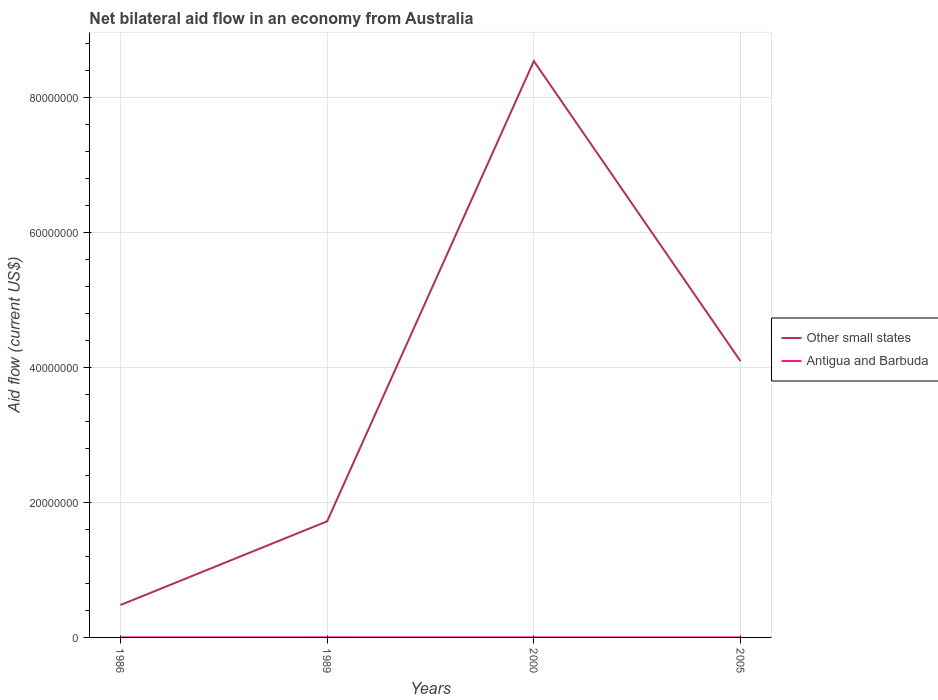Does the line corresponding to Other small states intersect with the line corresponding to Antigua and Barbuda?
Ensure brevity in your answer.  No. Is the number of lines equal to the number of legend labels?
Make the answer very short. Yes. Across all years, what is the maximum net bilateral aid flow in Antigua and Barbuda?
Offer a very short reply. 10000. In which year was the net bilateral aid flow in Antigua and Barbuda maximum?
Make the answer very short. 1986. What is the total net bilateral aid flow in Antigua and Barbuda in the graph?
Your answer should be very brief. 0. What is the difference between the highest and the second highest net bilateral aid flow in Other small states?
Ensure brevity in your answer.  8.06e+07. How many years are there in the graph?
Your answer should be compact. 4. Does the graph contain any zero values?
Give a very brief answer. No. Does the graph contain grids?
Your response must be concise. Yes. Where does the legend appear in the graph?
Keep it short and to the point. Center right. How are the legend labels stacked?
Offer a very short reply. Vertical. What is the title of the graph?
Keep it short and to the point. Net bilateral aid flow in an economy from Australia. Does "High income: OECD" appear as one of the legend labels in the graph?
Your response must be concise. No. What is the Aid flow (current US$) in Other small states in 1986?
Offer a very short reply. 4.80e+06. What is the Aid flow (current US$) in Other small states in 1989?
Offer a very short reply. 1.72e+07. What is the Aid flow (current US$) in Other small states in 2000?
Your answer should be very brief. 8.54e+07. What is the Aid flow (current US$) of Antigua and Barbuda in 2000?
Your answer should be compact. 10000. What is the Aid flow (current US$) of Other small states in 2005?
Keep it short and to the point. 4.09e+07. What is the Aid flow (current US$) in Antigua and Barbuda in 2005?
Provide a short and direct response. 10000. Across all years, what is the maximum Aid flow (current US$) in Other small states?
Provide a short and direct response. 8.54e+07. Across all years, what is the maximum Aid flow (current US$) of Antigua and Barbuda?
Make the answer very short. 2.00e+04. Across all years, what is the minimum Aid flow (current US$) in Other small states?
Provide a succinct answer. 4.80e+06. Across all years, what is the minimum Aid flow (current US$) of Antigua and Barbuda?
Ensure brevity in your answer.  10000. What is the total Aid flow (current US$) in Other small states in the graph?
Keep it short and to the point. 1.48e+08. What is the difference between the Aid flow (current US$) in Other small states in 1986 and that in 1989?
Ensure brevity in your answer.  -1.24e+07. What is the difference between the Aid flow (current US$) in Other small states in 1986 and that in 2000?
Make the answer very short. -8.06e+07. What is the difference between the Aid flow (current US$) in Other small states in 1986 and that in 2005?
Your response must be concise. -3.61e+07. What is the difference between the Aid flow (current US$) of Other small states in 1989 and that in 2000?
Ensure brevity in your answer.  -6.82e+07. What is the difference between the Aid flow (current US$) of Other small states in 1989 and that in 2005?
Make the answer very short. -2.37e+07. What is the difference between the Aid flow (current US$) in Antigua and Barbuda in 1989 and that in 2005?
Ensure brevity in your answer.  10000. What is the difference between the Aid flow (current US$) of Other small states in 2000 and that in 2005?
Provide a succinct answer. 4.45e+07. What is the difference between the Aid flow (current US$) of Other small states in 1986 and the Aid flow (current US$) of Antigua and Barbuda in 1989?
Provide a succinct answer. 4.78e+06. What is the difference between the Aid flow (current US$) of Other small states in 1986 and the Aid flow (current US$) of Antigua and Barbuda in 2000?
Provide a short and direct response. 4.79e+06. What is the difference between the Aid flow (current US$) in Other small states in 1986 and the Aid flow (current US$) in Antigua and Barbuda in 2005?
Offer a very short reply. 4.79e+06. What is the difference between the Aid flow (current US$) in Other small states in 1989 and the Aid flow (current US$) in Antigua and Barbuda in 2000?
Your response must be concise. 1.72e+07. What is the difference between the Aid flow (current US$) in Other small states in 1989 and the Aid flow (current US$) in Antigua and Barbuda in 2005?
Offer a very short reply. 1.72e+07. What is the difference between the Aid flow (current US$) of Other small states in 2000 and the Aid flow (current US$) of Antigua and Barbuda in 2005?
Keep it short and to the point. 8.54e+07. What is the average Aid flow (current US$) in Other small states per year?
Make the answer very short. 3.71e+07. What is the average Aid flow (current US$) of Antigua and Barbuda per year?
Offer a terse response. 1.25e+04. In the year 1986, what is the difference between the Aid flow (current US$) of Other small states and Aid flow (current US$) of Antigua and Barbuda?
Offer a terse response. 4.79e+06. In the year 1989, what is the difference between the Aid flow (current US$) in Other small states and Aid flow (current US$) in Antigua and Barbuda?
Your response must be concise. 1.72e+07. In the year 2000, what is the difference between the Aid flow (current US$) in Other small states and Aid flow (current US$) in Antigua and Barbuda?
Make the answer very short. 8.54e+07. In the year 2005, what is the difference between the Aid flow (current US$) in Other small states and Aid flow (current US$) in Antigua and Barbuda?
Provide a short and direct response. 4.09e+07. What is the ratio of the Aid flow (current US$) of Other small states in 1986 to that in 1989?
Offer a very short reply. 0.28. What is the ratio of the Aid flow (current US$) in Antigua and Barbuda in 1986 to that in 1989?
Your answer should be very brief. 0.5. What is the ratio of the Aid flow (current US$) of Other small states in 1986 to that in 2000?
Give a very brief answer. 0.06. What is the ratio of the Aid flow (current US$) of Other small states in 1986 to that in 2005?
Offer a very short reply. 0.12. What is the ratio of the Aid flow (current US$) in Antigua and Barbuda in 1986 to that in 2005?
Your answer should be compact. 1. What is the ratio of the Aid flow (current US$) of Other small states in 1989 to that in 2000?
Provide a succinct answer. 0.2. What is the ratio of the Aid flow (current US$) of Other small states in 1989 to that in 2005?
Your answer should be compact. 0.42. What is the ratio of the Aid flow (current US$) of Other small states in 2000 to that in 2005?
Provide a succinct answer. 2.09. What is the difference between the highest and the second highest Aid flow (current US$) in Other small states?
Give a very brief answer. 4.45e+07. What is the difference between the highest and the lowest Aid flow (current US$) in Other small states?
Ensure brevity in your answer.  8.06e+07. What is the difference between the highest and the lowest Aid flow (current US$) in Antigua and Barbuda?
Offer a very short reply. 10000. 